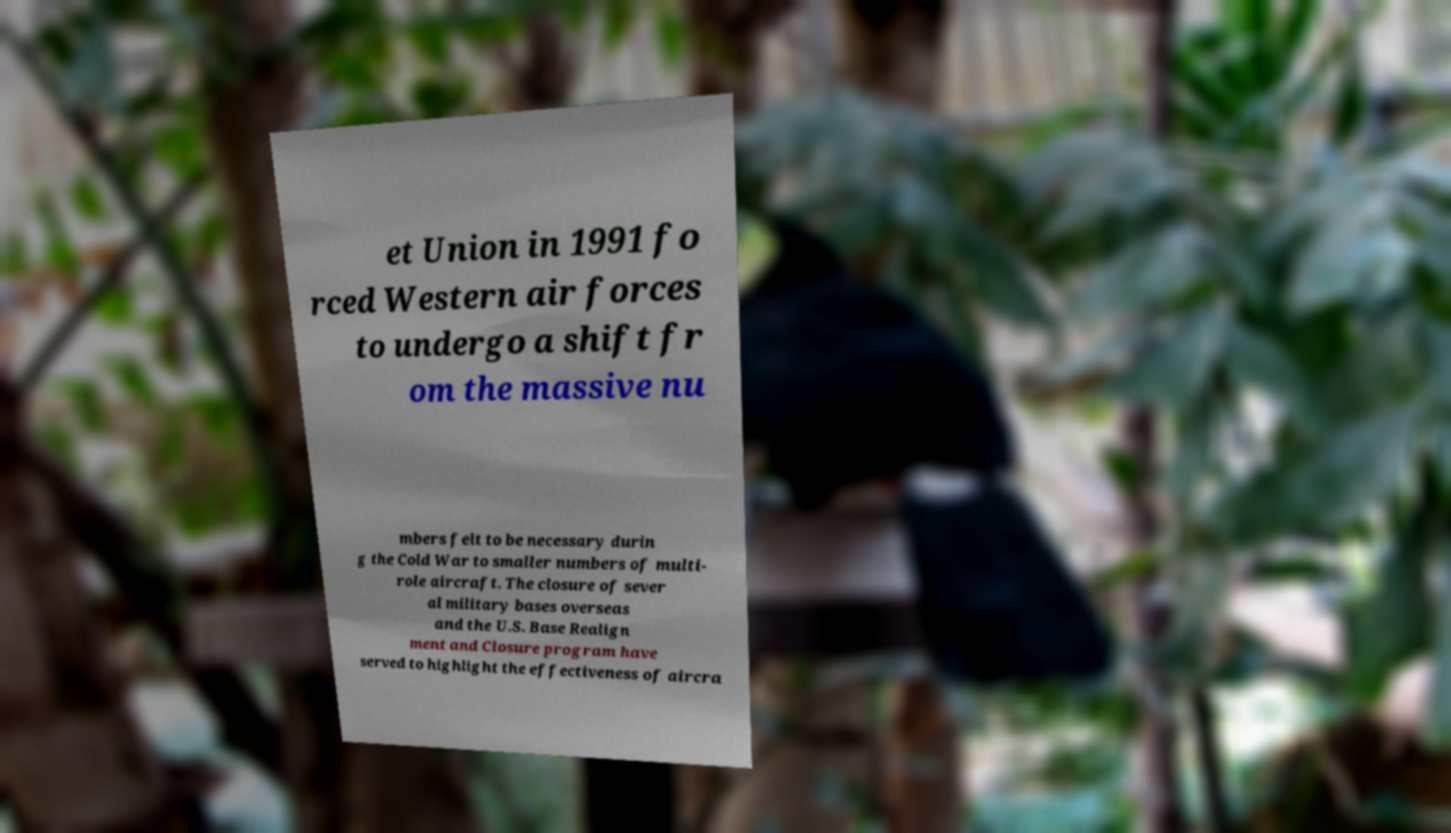For documentation purposes, I need the text within this image transcribed. Could you provide that? et Union in 1991 fo rced Western air forces to undergo a shift fr om the massive nu mbers felt to be necessary durin g the Cold War to smaller numbers of multi- role aircraft. The closure of sever al military bases overseas and the U.S. Base Realign ment and Closure program have served to highlight the effectiveness of aircra 